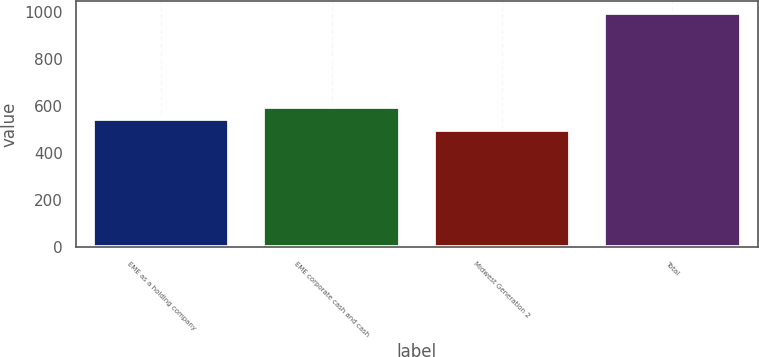Convert chart. <chart><loc_0><loc_0><loc_500><loc_500><bar_chart><fcel>EME as a holding company<fcel>EME corporate cash and cash<fcel>Midwest Generation 2<fcel>Total<nl><fcel>546.8<fcel>596.6<fcel>497<fcel>995<nl></chart> 